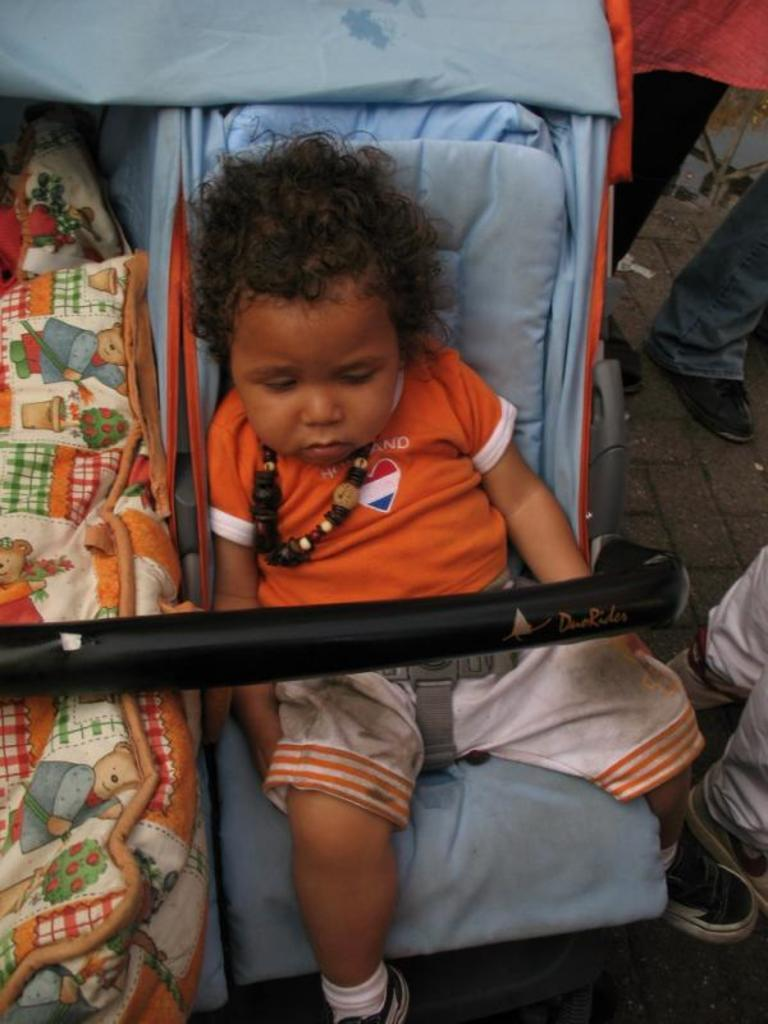What is the main subject of the image? The main subject of the image is a kid seated on a baby trolley. Are there any other baby trolleys in the image? Yes, there is another baby trolley on the left side of the image. What else can be seen in the image? Human legs are visible on the right side of the image. What type of beef is being exchanged between the accounts in the image? There is no beef or accounts present in the image; it features a kid seated on a baby trolley and another baby trolley on the left side of the image. 